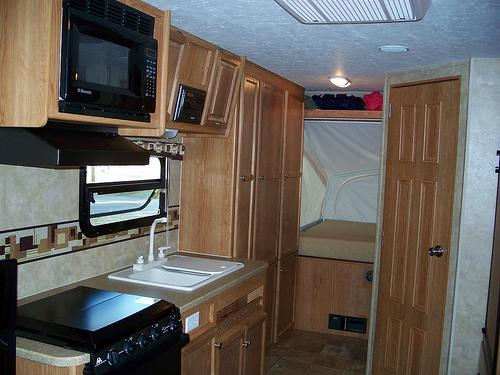What is the main color of the floor tiles in the image? The floor tiles are primarily brown in color. How many visible doors are in the image, and what are their colors? There are two visible doors in the image - both are brown. Can you describe the overall style and mood of the kitchen in the image? The kitchen has a contemporary and cozy style with brown tones, showcasing a warm and inviting atmosphere. Is there any pink object in the image? If yes, where can it be found? Yes, there is a pink bag near the light in the image. What appliances are in the kitchen, and what are their colors? The kitchen features a black microwave, a black oven range, and a white sink on the counter. Explain the arrangement of objects between the kitchen sink and the door across from it. Between the kitchen sink and the door across from it, there is a black range near the sink and a white outlet next to the dishwasher. The sink has a window behind it, and a brown door is closed near the kitchen area. Mention the areas where you can find black objects in the photo. In the photo, there are black objects on the window frame, microwave, oven range, and cover on the window. Which object is situated above the sink in the picture? There is a window above the kitchen sink in the image. Briefly describe the sink area and what's around it. The sink in the image is white with a white faucet, surrounded by a brown countertop and cabinets, with a black range nearby and a window behind the faucet. What is the shape of the light on the ceiling, and is it turned on or off? The shape of the light on the ceiling is not mentioned, but the small light is on. 